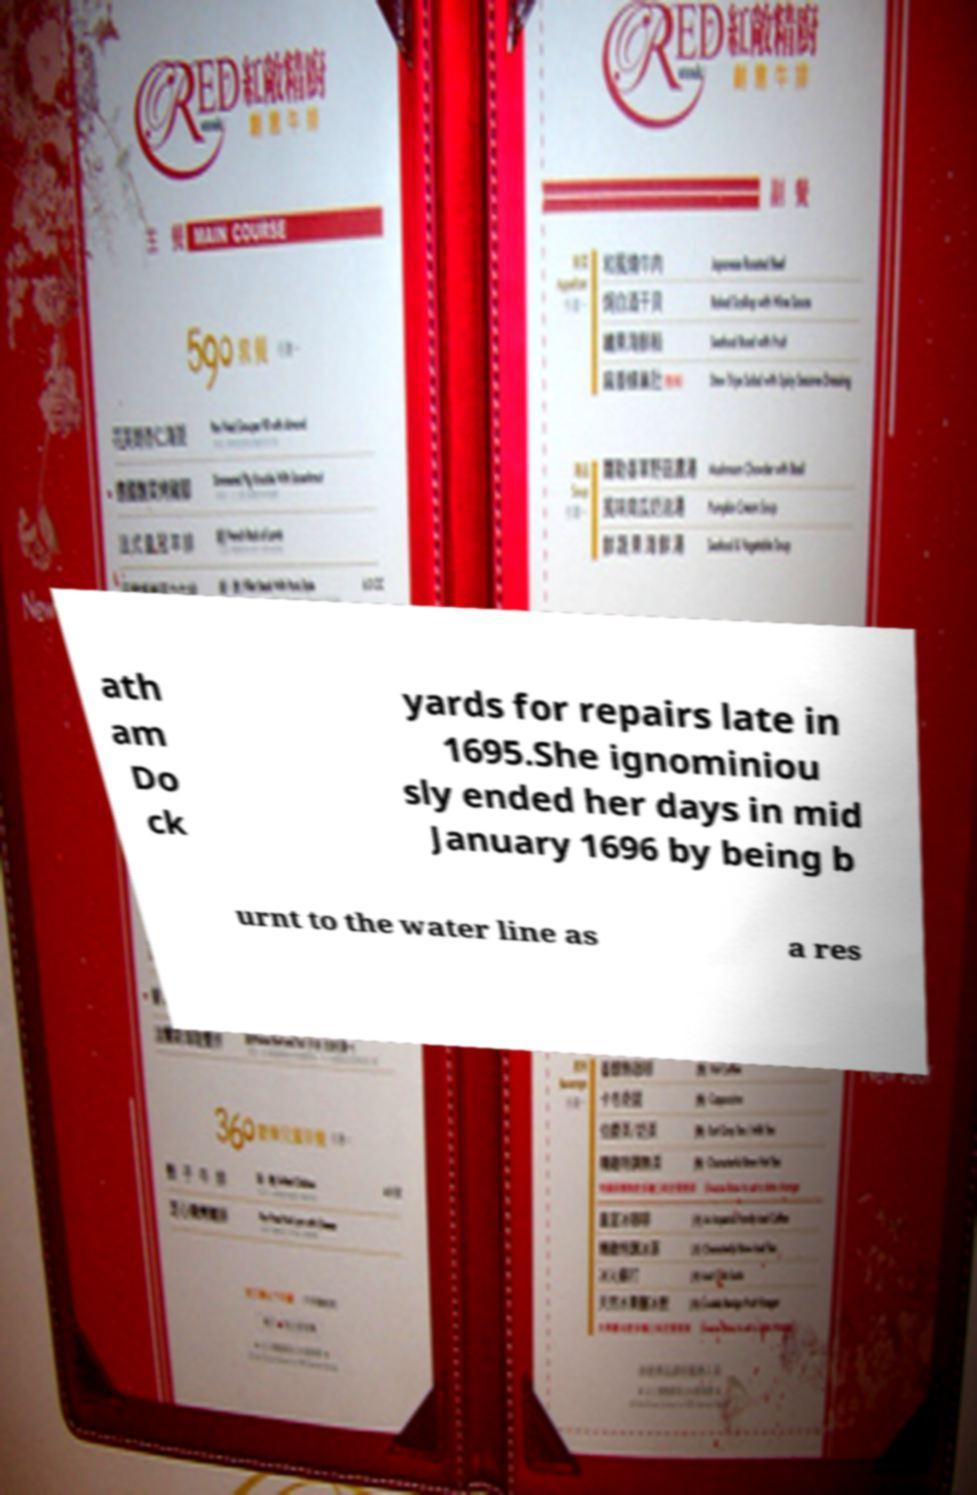For documentation purposes, I need the text within this image transcribed. Could you provide that? ath am Do ck yards for repairs late in 1695.She ignominiou sly ended her days in mid January 1696 by being b urnt to the water line as a res 